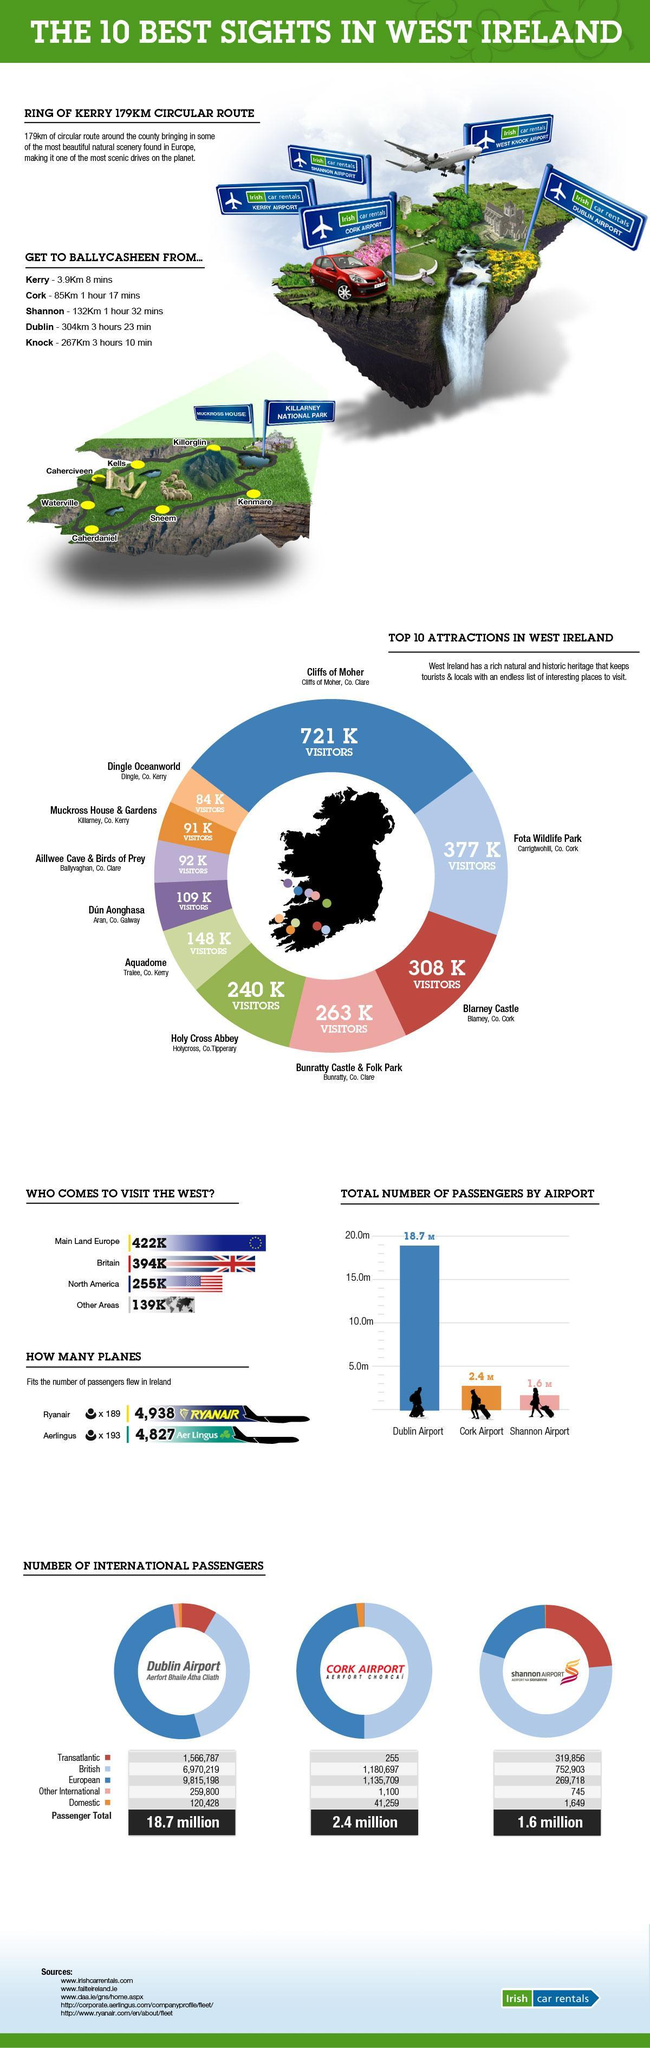What is the total number of domestic passengers in all three airports ?
Answer the question with a short phrase. 163,336 How many airports are there in West Ireland? 5 Which color denotes the second lowest number of visitors, orange, violet, or blue? orange Which color denotes the number of visitors to Blarney castle green, pink , or red ? red What is the total number of passengers arriving through Dublin, Cork, and Shannon airports ? 22.7 M 